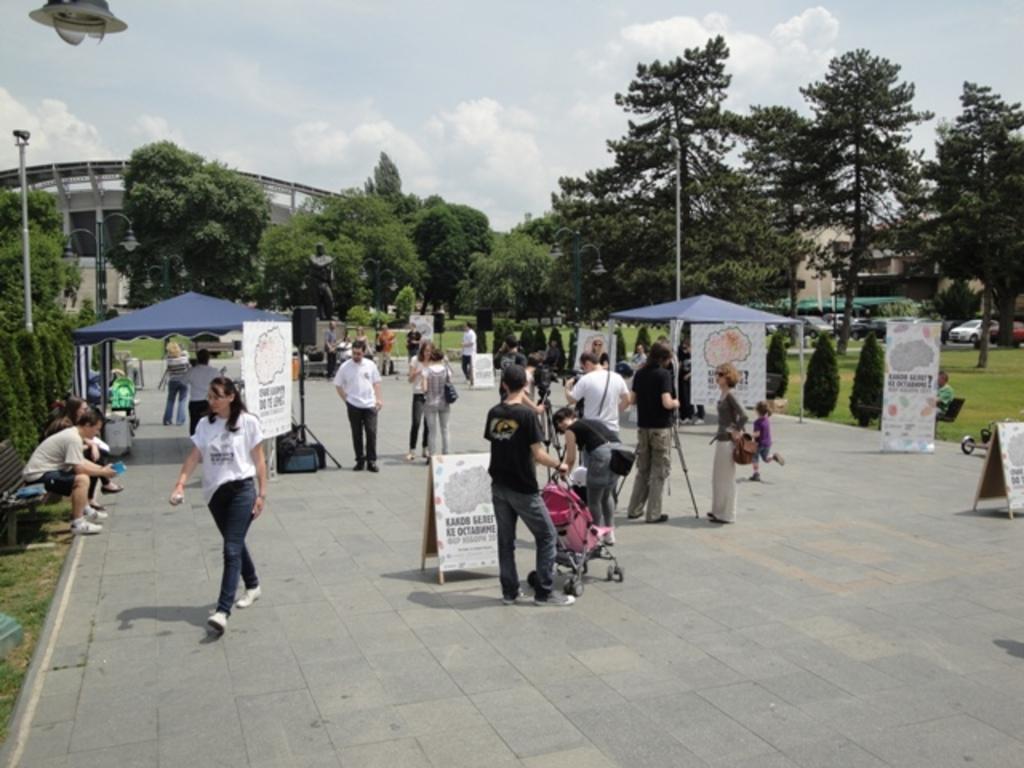In one or two sentences, can you explain what this image depicts? The picture is taken outside a building. In the foreground of the picture there are tents, hoardings, speakers, people, carts ,grass and plants. In the center of the picture there are trees, building and lights and cars. it is sunny. At the top, towards left there is a light. 